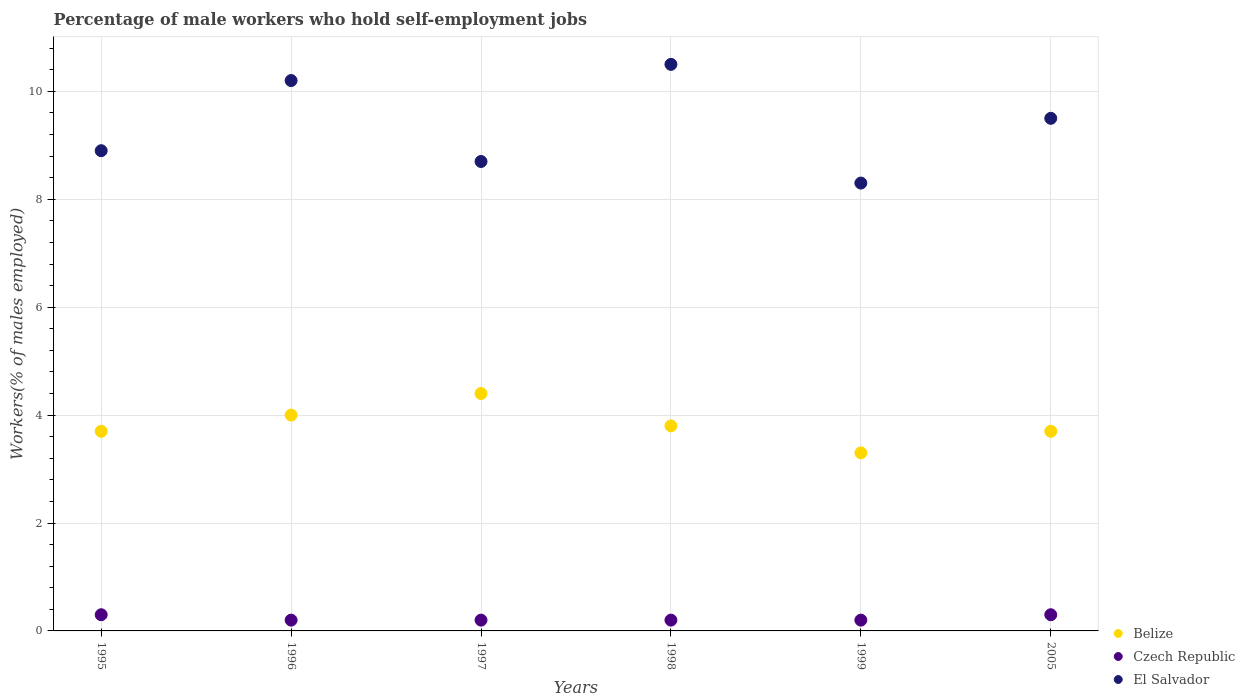How many different coloured dotlines are there?
Your answer should be very brief. 3. What is the percentage of self-employed male workers in Czech Republic in 1998?
Offer a very short reply. 0.2. Across all years, what is the minimum percentage of self-employed male workers in Czech Republic?
Your answer should be compact. 0.2. In which year was the percentage of self-employed male workers in Belize maximum?
Give a very brief answer. 1997. What is the total percentage of self-employed male workers in El Salvador in the graph?
Give a very brief answer. 56.1. What is the difference between the percentage of self-employed male workers in El Salvador in 1996 and that in 1999?
Make the answer very short. 1.9. What is the difference between the percentage of self-employed male workers in El Salvador in 1995 and the percentage of self-employed male workers in Czech Republic in 2005?
Your response must be concise. 8.6. What is the average percentage of self-employed male workers in Belize per year?
Keep it short and to the point. 3.82. In the year 1996, what is the difference between the percentage of self-employed male workers in Czech Republic and percentage of self-employed male workers in El Salvador?
Offer a terse response. -10. In how many years, is the percentage of self-employed male workers in El Salvador greater than 6 %?
Make the answer very short. 6. What is the ratio of the percentage of self-employed male workers in El Salvador in 1995 to that in 2005?
Offer a very short reply. 0.94. Is the difference between the percentage of self-employed male workers in Czech Republic in 1995 and 1996 greater than the difference between the percentage of self-employed male workers in El Salvador in 1995 and 1996?
Provide a succinct answer. Yes. What is the difference between the highest and the second highest percentage of self-employed male workers in Belize?
Provide a short and direct response. 0.4. What is the difference between the highest and the lowest percentage of self-employed male workers in Czech Republic?
Ensure brevity in your answer.  0.1. Is the sum of the percentage of self-employed male workers in Czech Republic in 1997 and 2005 greater than the maximum percentage of self-employed male workers in Belize across all years?
Provide a short and direct response. No. Does the percentage of self-employed male workers in El Salvador monotonically increase over the years?
Keep it short and to the point. No. Is the percentage of self-employed male workers in Belize strictly less than the percentage of self-employed male workers in Czech Republic over the years?
Your answer should be compact. No. Does the graph contain any zero values?
Your answer should be very brief. No. How many legend labels are there?
Make the answer very short. 3. How are the legend labels stacked?
Your answer should be compact. Vertical. What is the title of the graph?
Provide a short and direct response. Percentage of male workers who hold self-employment jobs. What is the label or title of the X-axis?
Give a very brief answer. Years. What is the label or title of the Y-axis?
Keep it short and to the point. Workers(% of males employed). What is the Workers(% of males employed) in Belize in 1995?
Ensure brevity in your answer.  3.7. What is the Workers(% of males employed) of Czech Republic in 1995?
Keep it short and to the point. 0.3. What is the Workers(% of males employed) in El Salvador in 1995?
Your answer should be compact. 8.9. What is the Workers(% of males employed) in Belize in 1996?
Your answer should be very brief. 4. What is the Workers(% of males employed) of Czech Republic in 1996?
Offer a terse response. 0.2. What is the Workers(% of males employed) in El Salvador in 1996?
Keep it short and to the point. 10.2. What is the Workers(% of males employed) in Belize in 1997?
Offer a terse response. 4.4. What is the Workers(% of males employed) in Czech Republic in 1997?
Your answer should be compact. 0.2. What is the Workers(% of males employed) of El Salvador in 1997?
Your answer should be compact. 8.7. What is the Workers(% of males employed) in Belize in 1998?
Offer a very short reply. 3.8. What is the Workers(% of males employed) in Czech Republic in 1998?
Make the answer very short. 0.2. What is the Workers(% of males employed) in Belize in 1999?
Provide a succinct answer. 3.3. What is the Workers(% of males employed) in Czech Republic in 1999?
Ensure brevity in your answer.  0.2. What is the Workers(% of males employed) in El Salvador in 1999?
Make the answer very short. 8.3. What is the Workers(% of males employed) of Belize in 2005?
Your answer should be very brief. 3.7. What is the Workers(% of males employed) of Czech Republic in 2005?
Give a very brief answer. 0.3. Across all years, what is the maximum Workers(% of males employed) of Belize?
Provide a short and direct response. 4.4. Across all years, what is the maximum Workers(% of males employed) in Czech Republic?
Ensure brevity in your answer.  0.3. Across all years, what is the maximum Workers(% of males employed) in El Salvador?
Your response must be concise. 10.5. Across all years, what is the minimum Workers(% of males employed) in Belize?
Make the answer very short. 3.3. Across all years, what is the minimum Workers(% of males employed) in Czech Republic?
Your answer should be very brief. 0.2. Across all years, what is the minimum Workers(% of males employed) in El Salvador?
Offer a very short reply. 8.3. What is the total Workers(% of males employed) of Belize in the graph?
Your response must be concise. 22.9. What is the total Workers(% of males employed) in Czech Republic in the graph?
Offer a very short reply. 1.4. What is the total Workers(% of males employed) of El Salvador in the graph?
Give a very brief answer. 56.1. What is the difference between the Workers(% of males employed) of Belize in 1995 and that in 1996?
Your answer should be compact. -0.3. What is the difference between the Workers(% of males employed) in Czech Republic in 1995 and that in 1997?
Your response must be concise. 0.1. What is the difference between the Workers(% of males employed) of El Salvador in 1995 and that in 1997?
Provide a short and direct response. 0.2. What is the difference between the Workers(% of males employed) of Belize in 1995 and that in 1998?
Provide a short and direct response. -0.1. What is the difference between the Workers(% of males employed) in El Salvador in 1995 and that in 1998?
Your answer should be very brief. -1.6. What is the difference between the Workers(% of males employed) in El Salvador in 1995 and that in 1999?
Provide a succinct answer. 0.6. What is the difference between the Workers(% of males employed) of Belize in 1996 and that in 1997?
Keep it short and to the point. -0.4. What is the difference between the Workers(% of males employed) of Czech Republic in 1996 and that in 1997?
Offer a very short reply. 0. What is the difference between the Workers(% of males employed) in Belize in 1996 and that in 1998?
Provide a succinct answer. 0.2. What is the difference between the Workers(% of males employed) in Czech Republic in 1996 and that in 1998?
Your response must be concise. 0. What is the difference between the Workers(% of males employed) of El Salvador in 1996 and that in 1998?
Provide a short and direct response. -0.3. What is the difference between the Workers(% of males employed) of Belize in 1996 and that in 1999?
Offer a very short reply. 0.7. What is the difference between the Workers(% of males employed) of El Salvador in 1996 and that in 1999?
Make the answer very short. 1.9. What is the difference between the Workers(% of males employed) of Czech Republic in 1996 and that in 2005?
Make the answer very short. -0.1. What is the difference between the Workers(% of males employed) in El Salvador in 1997 and that in 1998?
Give a very brief answer. -1.8. What is the difference between the Workers(% of males employed) of Belize in 1997 and that in 1999?
Provide a succinct answer. 1.1. What is the difference between the Workers(% of males employed) of Czech Republic in 1997 and that in 1999?
Offer a very short reply. 0. What is the difference between the Workers(% of males employed) in Czech Republic in 1997 and that in 2005?
Give a very brief answer. -0.1. What is the difference between the Workers(% of males employed) in Belize in 1998 and that in 1999?
Offer a terse response. 0.5. What is the difference between the Workers(% of males employed) in Belize in 1998 and that in 2005?
Offer a very short reply. 0.1. What is the difference between the Workers(% of males employed) of Czech Republic in 1998 and that in 2005?
Your answer should be very brief. -0.1. What is the difference between the Workers(% of males employed) in El Salvador in 1998 and that in 2005?
Your answer should be compact. 1. What is the difference between the Workers(% of males employed) of Czech Republic in 1999 and that in 2005?
Give a very brief answer. -0.1. What is the difference between the Workers(% of males employed) of El Salvador in 1999 and that in 2005?
Give a very brief answer. -1.2. What is the difference between the Workers(% of males employed) of Czech Republic in 1995 and the Workers(% of males employed) of El Salvador in 1996?
Provide a succinct answer. -9.9. What is the difference between the Workers(% of males employed) in Belize in 1995 and the Workers(% of males employed) in El Salvador in 1997?
Offer a very short reply. -5. What is the difference between the Workers(% of males employed) of Czech Republic in 1995 and the Workers(% of males employed) of El Salvador in 1997?
Make the answer very short. -8.4. What is the difference between the Workers(% of males employed) in Belize in 1995 and the Workers(% of males employed) in Czech Republic in 1998?
Your answer should be very brief. 3.5. What is the difference between the Workers(% of males employed) of Belize in 1995 and the Workers(% of males employed) of El Salvador in 1998?
Ensure brevity in your answer.  -6.8. What is the difference between the Workers(% of males employed) in Belize in 1995 and the Workers(% of males employed) in Czech Republic in 1999?
Offer a very short reply. 3.5. What is the difference between the Workers(% of males employed) of Belize in 1995 and the Workers(% of males employed) of El Salvador in 1999?
Make the answer very short. -4.6. What is the difference between the Workers(% of males employed) of Czech Republic in 1995 and the Workers(% of males employed) of El Salvador in 1999?
Keep it short and to the point. -8. What is the difference between the Workers(% of males employed) of Belize in 1995 and the Workers(% of males employed) of Czech Republic in 2005?
Your answer should be compact. 3.4. What is the difference between the Workers(% of males employed) of Belize in 1996 and the Workers(% of males employed) of Czech Republic in 1997?
Make the answer very short. 3.8. What is the difference between the Workers(% of males employed) of Belize in 1996 and the Workers(% of males employed) of El Salvador in 1997?
Your answer should be very brief. -4.7. What is the difference between the Workers(% of males employed) in Czech Republic in 1996 and the Workers(% of males employed) in El Salvador in 1997?
Make the answer very short. -8.5. What is the difference between the Workers(% of males employed) in Belize in 1996 and the Workers(% of males employed) in Czech Republic in 1998?
Offer a terse response. 3.8. What is the difference between the Workers(% of males employed) of Czech Republic in 1996 and the Workers(% of males employed) of El Salvador in 1998?
Provide a short and direct response. -10.3. What is the difference between the Workers(% of males employed) in Czech Republic in 1996 and the Workers(% of males employed) in El Salvador in 1999?
Keep it short and to the point. -8.1. What is the difference between the Workers(% of males employed) of Belize in 1996 and the Workers(% of males employed) of Czech Republic in 2005?
Make the answer very short. 3.7. What is the difference between the Workers(% of males employed) in Belize in 1996 and the Workers(% of males employed) in El Salvador in 2005?
Provide a short and direct response. -5.5. What is the difference between the Workers(% of males employed) of Belize in 1997 and the Workers(% of males employed) of El Salvador in 1998?
Offer a very short reply. -6.1. What is the difference between the Workers(% of males employed) of Belize in 1997 and the Workers(% of males employed) of El Salvador in 1999?
Provide a short and direct response. -3.9. What is the difference between the Workers(% of males employed) of Belize in 1997 and the Workers(% of males employed) of Czech Republic in 2005?
Provide a succinct answer. 4.1. What is the difference between the Workers(% of males employed) of Belize in 1998 and the Workers(% of males employed) of Czech Republic in 1999?
Give a very brief answer. 3.6. What is the difference between the Workers(% of males employed) in Belize in 1998 and the Workers(% of males employed) in El Salvador in 1999?
Keep it short and to the point. -4.5. What is the difference between the Workers(% of males employed) in Czech Republic in 1998 and the Workers(% of males employed) in El Salvador in 1999?
Your answer should be compact. -8.1. What is the difference between the Workers(% of males employed) in Belize in 1998 and the Workers(% of males employed) in El Salvador in 2005?
Offer a terse response. -5.7. What is the difference between the Workers(% of males employed) of Belize in 1999 and the Workers(% of males employed) of El Salvador in 2005?
Your answer should be compact. -6.2. What is the average Workers(% of males employed) of Belize per year?
Offer a very short reply. 3.82. What is the average Workers(% of males employed) of Czech Republic per year?
Provide a succinct answer. 0.23. What is the average Workers(% of males employed) of El Salvador per year?
Offer a very short reply. 9.35. In the year 1995, what is the difference between the Workers(% of males employed) of Belize and Workers(% of males employed) of Czech Republic?
Ensure brevity in your answer.  3.4. In the year 1995, what is the difference between the Workers(% of males employed) in Belize and Workers(% of males employed) in El Salvador?
Make the answer very short. -5.2. In the year 1996, what is the difference between the Workers(% of males employed) of Belize and Workers(% of males employed) of Czech Republic?
Your answer should be very brief. 3.8. In the year 1996, what is the difference between the Workers(% of males employed) of Belize and Workers(% of males employed) of El Salvador?
Ensure brevity in your answer.  -6.2. In the year 1997, what is the difference between the Workers(% of males employed) of Belize and Workers(% of males employed) of El Salvador?
Give a very brief answer. -4.3. In the year 1997, what is the difference between the Workers(% of males employed) of Czech Republic and Workers(% of males employed) of El Salvador?
Provide a short and direct response. -8.5. In the year 1998, what is the difference between the Workers(% of males employed) in Belize and Workers(% of males employed) in Czech Republic?
Provide a short and direct response. 3.6. In the year 1999, what is the difference between the Workers(% of males employed) of Belize and Workers(% of males employed) of Czech Republic?
Make the answer very short. 3.1. In the year 1999, what is the difference between the Workers(% of males employed) of Belize and Workers(% of males employed) of El Salvador?
Provide a short and direct response. -5. In the year 1999, what is the difference between the Workers(% of males employed) in Czech Republic and Workers(% of males employed) in El Salvador?
Offer a very short reply. -8.1. What is the ratio of the Workers(% of males employed) in Belize in 1995 to that in 1996?
Provide a short and direct response. 0.93. What is the ratio of the Workers(% of males employed) in El Salvador in 1995 to that in 1996?
Give a very brief answer. 0.87. What is the ratio of the Workers(% of males employed) of Belize in 1995 to that in 1997?
Your answer should be very brief. 0.84. What is the ratio of the Workers(% of males employed) in Czech Republic in 1995 to that in 1997?
Your answer should be very brief. 1.5. What is the ratio of the Workers(% of males employed) in Belize in 1995 to that in 1998?
Your answer should be very brief. 0.97. What is the ratio of the Workers(% of males employed) of Czech Republic in 1995 to that in 1998?
Provide a succinct answer. 1.5. What is the ratio of the Workers(% of males employed) of El Salvador in 1995 to that in 1998?
Your response must be concise. 0.85. What is the ratio of the Workers(% of males employed) of Belize in 1995 to that in 1999?
Provide a succinct answer. 1.12. What is the ratio of the Workers(% of males employed) of Czech Republic in 1995 to that in 1999?
Ensure brevity in your answer.  1.5. What is the ratio of the Workers(% of males employed) in El Salvador in 1995 to that in 1999?
Offer a very short reply. 1.07. What is the ratio of the Workers(% of males employed) in Belize in 1995 to that in 2005?
Offer a very short reply. 1. What is the ratio of the Workers(% of males employed) of El Salvador in 1995 to that in 2005?
Offer a terse response. 0.94. What is the ratio of the Workers(% of males employed) of El Salvador in 1996 to that in 1997?
Offer a very short reply. 1.17. What is the ratio of the Workers(% of males employed) in Belize in 1996 to that in 1998?
Provide a succinct answer. 1.05. What is the ratio of the Workers(% of males employed) of El Salvador in 1996 to that in 1998?
Give a very brief answer. 0.97. What is the ratio of the Workers(% of males employed) of Belize in 1996 to that in 1999?
Offer a terse response. 1.21. What is the ratio of the Workers(% of males employed) of Czech Republic in 1996 to that in 1999?
Your response must be concise. 1. What is the ratio of the Workers(% of males employed) in El Salvador in 1996 to that in 1999?
Offer a terse response. 1.23. What is the ratio of the Workers(% of males employed) in Belize in 1996 to that in 2005?
Your answer should be compact. 1.08. What is the ratio of the Workers(% of males employed) in Czech Republic in 1996 to that in 2005?
Offer a very short reply. 0.67. What is the ratio of the Workers(% of males employed) in El Salvador in 1996 to that in 2005?
Offer a very short reply. 1.07. What is the ratio of the Workers(% of males employed) in Belize in 1997 to that in 1998?
Make the answer very short. 1.16. What is the ratio of the Workers(% of males employed) of El Salvador in 1997 to that in 1998?
Your response must be concise. 0.83. What is the ratio of the Workers(% of males employed) in Czech Republic in 1997 to that in 1999?
Your response must be concise. 1. What is the ratio of the Workers(% of males employed) in El Salvador in 1997 to that in 1999?
Provide a short and direct response. 1.05. What is the ratio of the Workers(% of males employed) of Belize in 1997 to that in 2005?
Give a very brief answer. 1.19. What is the ratio of the Workers(% of males employed) in Czech Republic in 1997 to that in 2005?
Keep it short and to the point. 0.67. What is the ratio of the Workers(% of males employed) of El Salvador in 1997 to that in 2005?
Your response must be concise. 0.92. What is the ratio of the Workers(% of males employed) in Belize in 1998 to that in 1999?
Offer a very short reply. 1.15. What is the ratio of the Workers(% of males employed) in Czech Republic in 1998 to that in 1999?
Give a very brief answer. 1. What is the ratio of the Workers(% of males employed) of El Salvador in 1998 to that in 1999?
Make the answer very short. 1.27. What is the ratio of the Workers(% of males employed) in Czech Republic in 1998 to that in 2005?
Your response must be concise. 0.67. What is the ratio of the Workers(% of males employed) in El Salvador in 1998 to that in 2005?
Provide a succinct answer. 1.11. What is the ratio of the Workers(% of males employed) in Belize in 1999 to that in 2005?
Ensure brevity in your answer.  0.89. What is the ratio of the Workers(% of males employed) of Czech Republic in 1999 to that in 2005?
Your answer should be compact. 0.67. What is the ratio of the Workers(% of males employed) in El Salvador in 1999 to that in 2005?
Your response must be concise. 0.87. What is the difference between the highest and the second highest Workers(% of males employed) of Czech Republic?
Your answer should be very brief. 0. 